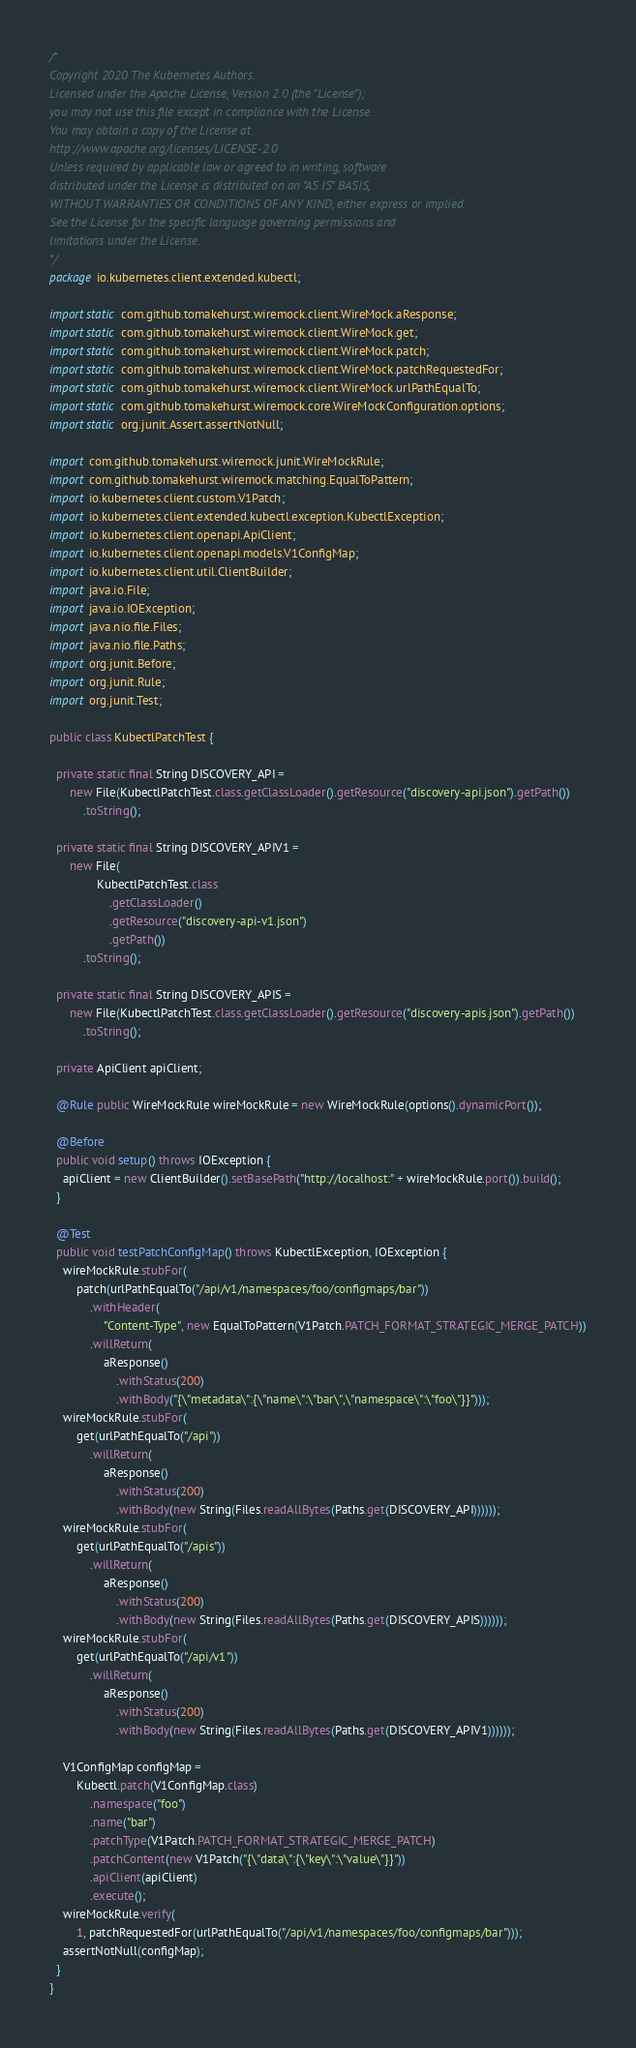<code> <loc_0><loc_0><loc_500><loc_500><_Java_>/*
Copyright 2020 The Kubernetes Authors.
Licensed under the Apache License, Version 2.0 (the "License");
you may not use this file except in compliance with the License.
You may obtain a copy of the License at
http://www.apache.org/licenses/LICENSE-2.0
Unless required by applicable law or agreed to in writing, software
distributed under the License is distributed on an "AS IS" BASIS,
WITHOUT WARRANTIES OR CONDITIONS OF ANY KIND, either express or implied.
See the License for the specific language governing permissions and
limitations under the License.
*/
package io.kubernetes.client.extended.kubectl;

import static com.github.tomakehurst.wiremock.client.WireMock.aResponse;
import static com.github.tomakehurst.wiremock.client.WireMock.get;
import static com.github.tomakehurst.wiremock.client.WireMock.patch;
import static com.github.tomakehurst.wiremock.client.WireMock.patchRequestedFor;
import static com.github.tomakehurst.wiremock.client.WireMock.urlPathEqualTo;
import static com.github.tomakehurst.wiremock.core.WireMockConfiguration.options;
import static org.junit.Assert.assertNotNull;

import com.github.tomakehurst.wiremock.junit.WireMockRule;
import com.github.tomakehurst.wiremock.matching.EqualToPattern;
import io.kubernetes.client.custom.V1Patch;
import io.kubernetes.client.extended.kubectl.exception.KubectlException;
import io.kubernetes.client.openapi.ApiClient;
import io.kubernetes.client.openapi.models.V1ConfigMap;
import io.kubernetes.client.util.ClientBuilder;
import java.io.File;
import java.io.IOException;
import java.nio.file.Files;
import java.nio.file.Paths;
import org.junit.Before;
import org.junit.Rule;
import org.junit.Test;

public class KubectlPatchTest {

  private static final String DISCOVERY_API =
      new File(KubectlPatchTest.class.getClassLoader().getResource("discovery-api.json").getPath())
          .toString();

  private static final String DISCOVERY_APIV1 =
      new File(
              KubectlPatchTest.class
                  .getClassLoader()
                  .getResource("discovery-api-v1.json")
                  .getPath())
          .toString();

  private static final String DISCOVERY_APIS =
      new File(KubectlPatchTest.class.getClassLoader().getResource("discovery-apis.json").getPath())
          .toString();

  private ApiClient apiClient;

  @Rule public WireMockRule wireMockRule = new WireMockRule(options().dynamicPort());

  @Before
  public void setup() throws IOException {
    apiClient = new ClientBuilder().setBasePath("http://localhost:" + wireMockRule.port()).build();
  }

  @Test
  public void testPatchConfigMap() throws KubectlException, IOException {
    wireMockRule.stubFor(
        patch(urlPathEqualTo("/api/v1/namespaces/foo/configmaps/bar"))
            .withHeader(
                "Content-Type", new EqualToPattern(V1Patch.PATCH_FORMAT_STRATEGIC_MERGE_PATCH))
            .willReturn(
                aResponse()
                    .withStatus(200)
                    .withBody("{\"metadata\":{\"name\":\"bar\",\"namespace\":\"foo\"}}")));
    wireMockRule.stubFor(
        get(urlPathEqualTo("/api"))
            .willReturn(
                aResponse()
                    .withStatus(200)
                    .withBody(new String(Files.readAllBytes(Paths.get(DISCOVERY_API))))));
    wireMockRule.stubFor(
        get(urlPathEqualTo("/apis"))
            .willReturn(
                aResponse()
                    .withStatus(200)
                    .withBody(new String(Files.readAllBytes(Paths.get(DISCOVERY_APIS))))));
    wireMockRule.stubFor(
        get(urlPathEqualTo("/api/v1"))
            .willReturn(
                aResponse()
                    .withStatus(200)
                    .withBody(new String(Files.readAllBytes(Paths.get(DISCOVERY_APIV1))))));

    V1ConfigMap configMap =
        Kubectl.patch(V1ConfigMap.class)
            .namespace("foo")
            .name("bar")
            .patchType(V1Patch.PATCH_FORMAT_STRATEGIC_MERGE_PATCH)
            .patchContent(new V1Patch("{\"data\":{\"key\":\"value\"}}"))
            .apiClient(apiClient)
            .execute();
    wireMockRule.verify(
        1, patchRequestedFor(urlPathEqualTo("/api/v1/namespaces/foo/configmaps/bar")));
    assertNotNull(configMap);
  }
}
</code> 